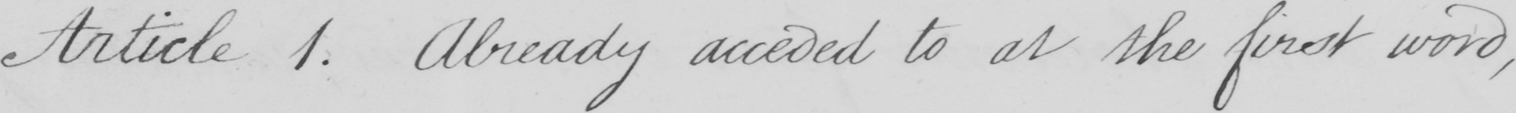Can you read and transcribe this handwriting? Article 1 . Already acceded to at the first word , 